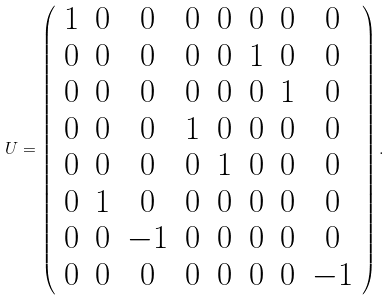Convert formula to latex. <formula><loc_0><loc_0><loc_500><loc_500>U = \left ( \begin{array} { c c c c c c c c } 1 & 0 & 0 & 0 & 0 & 0 & 0 & 0 \\ 0 & 0 & 0 & 0 & 0 & 1 & 0 & 0 \\ 0 & 0 & 0 & 0 & 0 & 0 & 1 & 0 \\ 0 & 0 & 0 & 1 & 0 & 0 & 0 & 0 \\ 0 & 0 & 0 & 0 & 1 & 0 & 0 & 0 \\ 0 & 1 & 0 & 0 & 0 & 0 & 0 & 0 \\ 0 & 0 & - 1 & 0 & 0 & 0 & 0 & 0 \\ 0 & 0 & 0 & 0 & 0 & 0 & 0 & - 1 \\ \end{array} \right ) .</formula> 